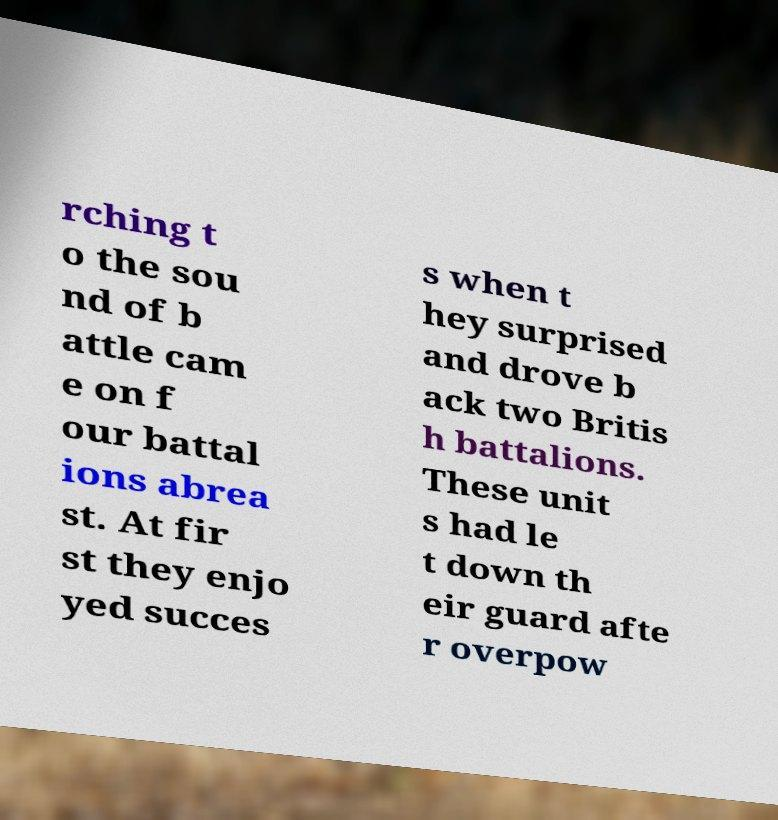What messages or text are displayed in this image? I need them in a readable, typed format. rching t o the sou nd of b attle cam e on f our battal ions abrea st. At fir st they enjo yed succes s when t hey surprised and drove b ack two Britis h battalions. These unit s had le t down th eir guard afte r overpow 